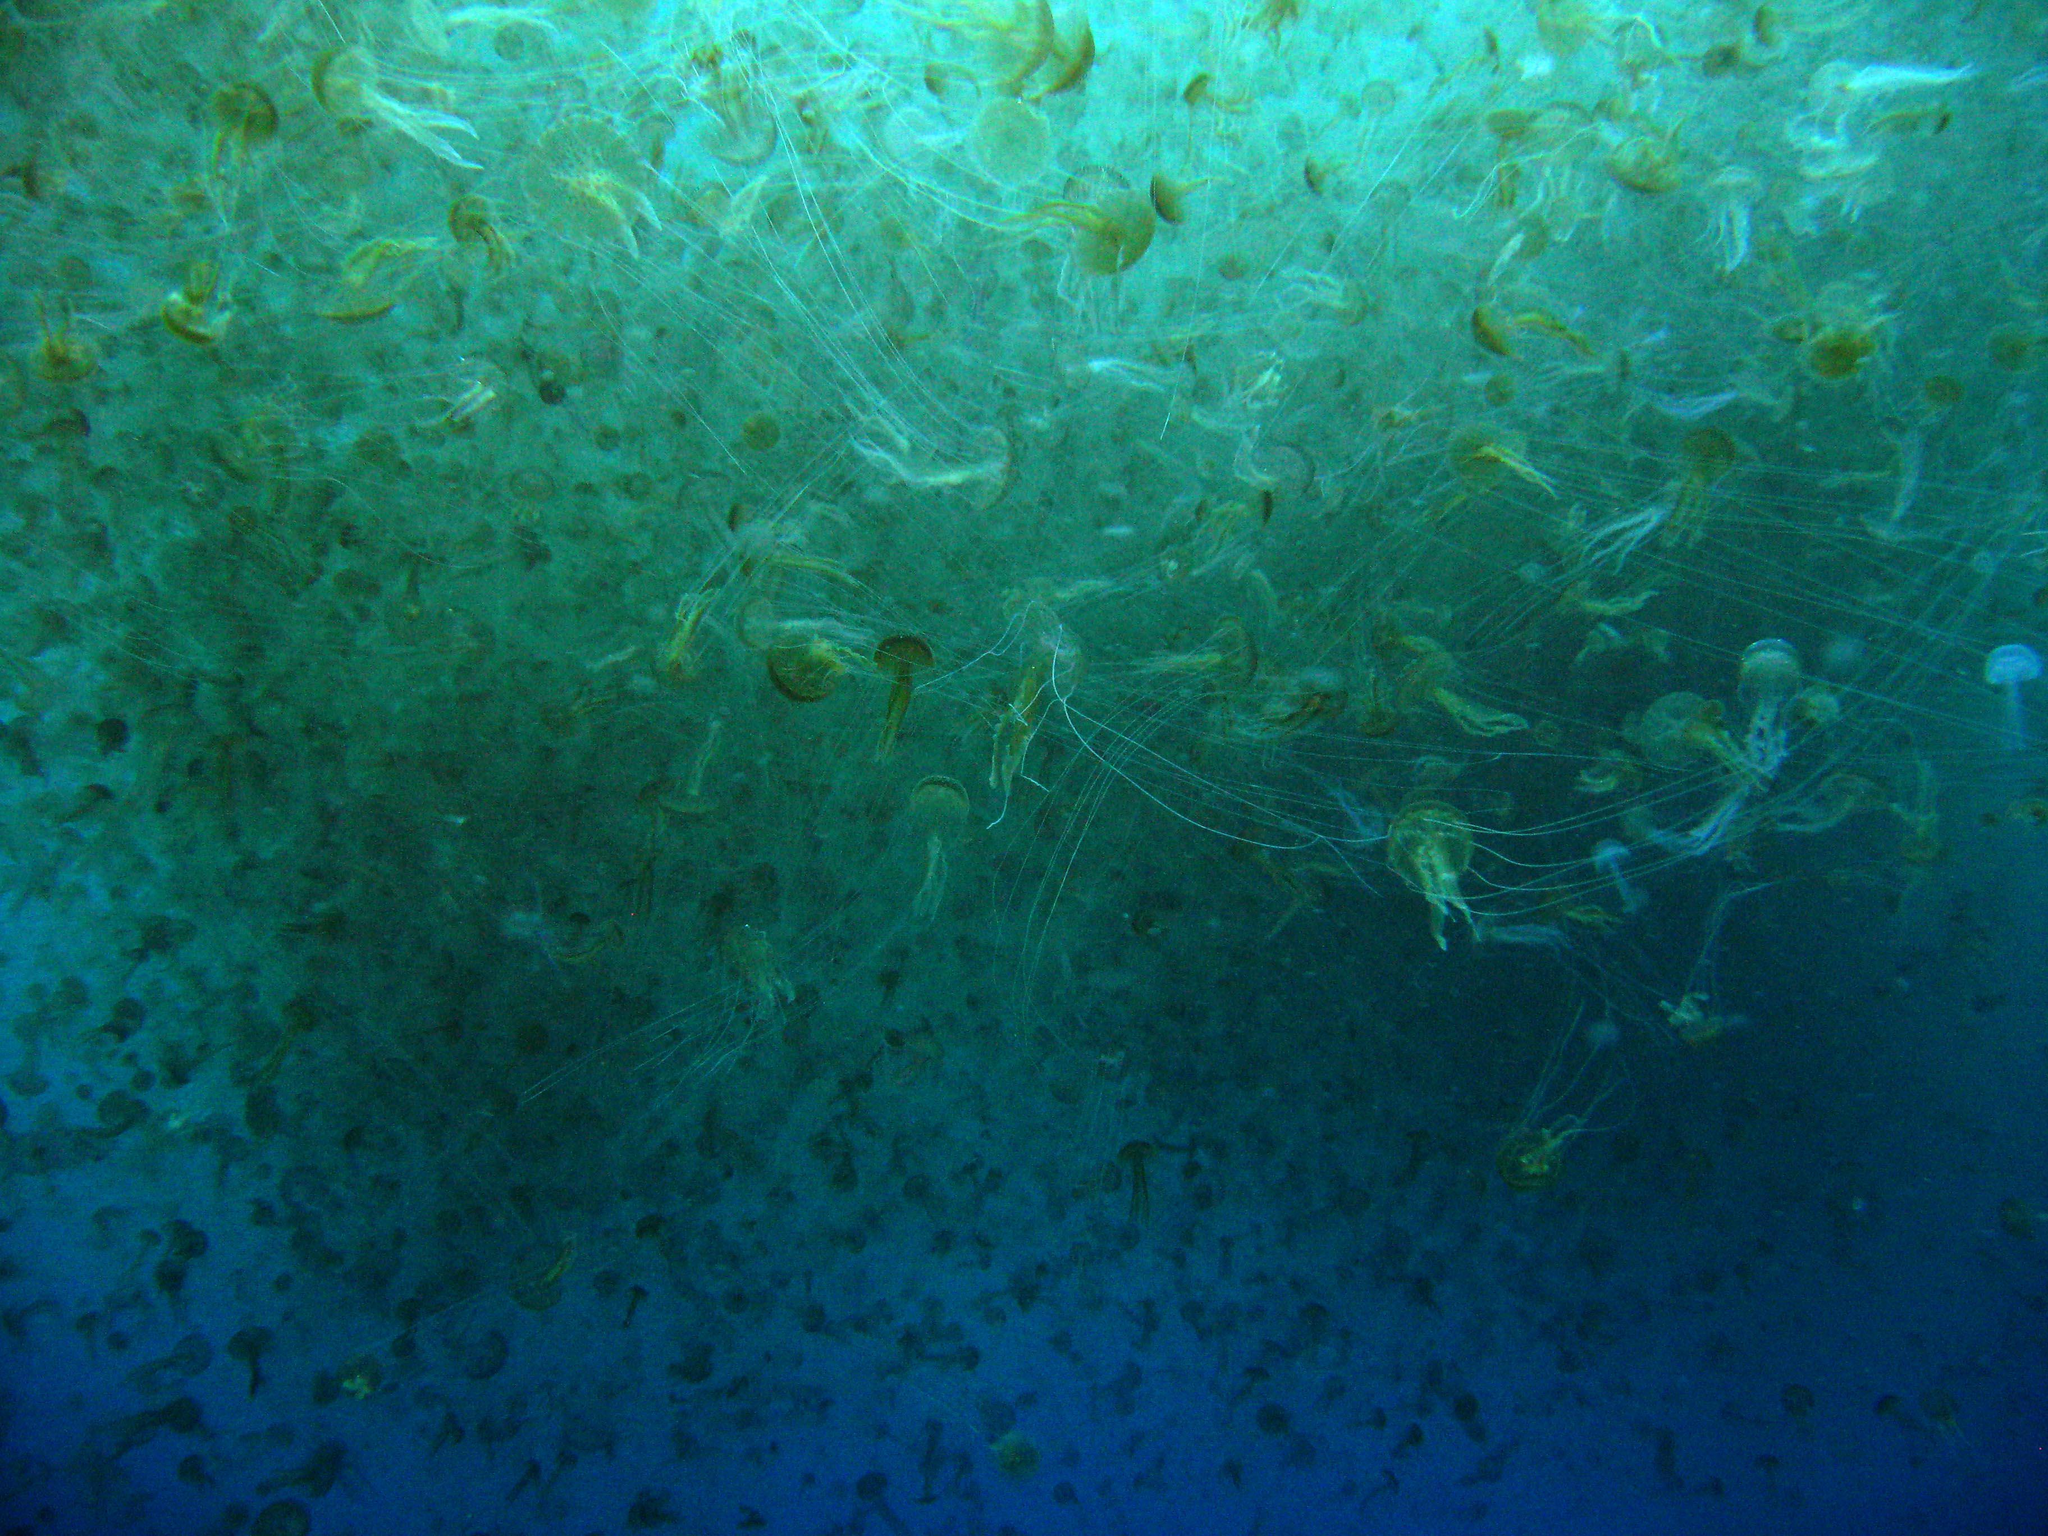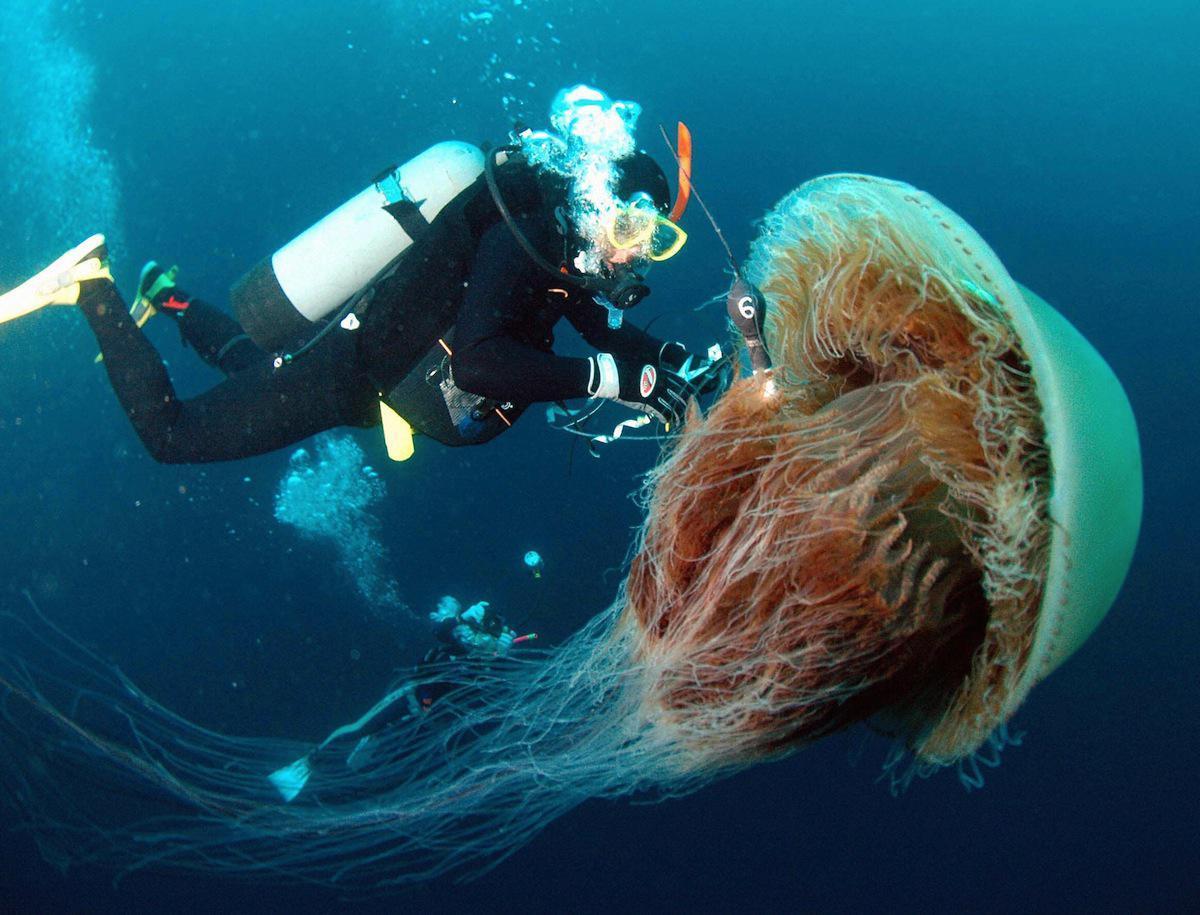The first image is the image on the left, the second image is the image on the right. Assess this claim about the two images: "An image shows at least six vivid orange jellyfish trailing tendrils.". Correct or not? Answer yes or no. No. 